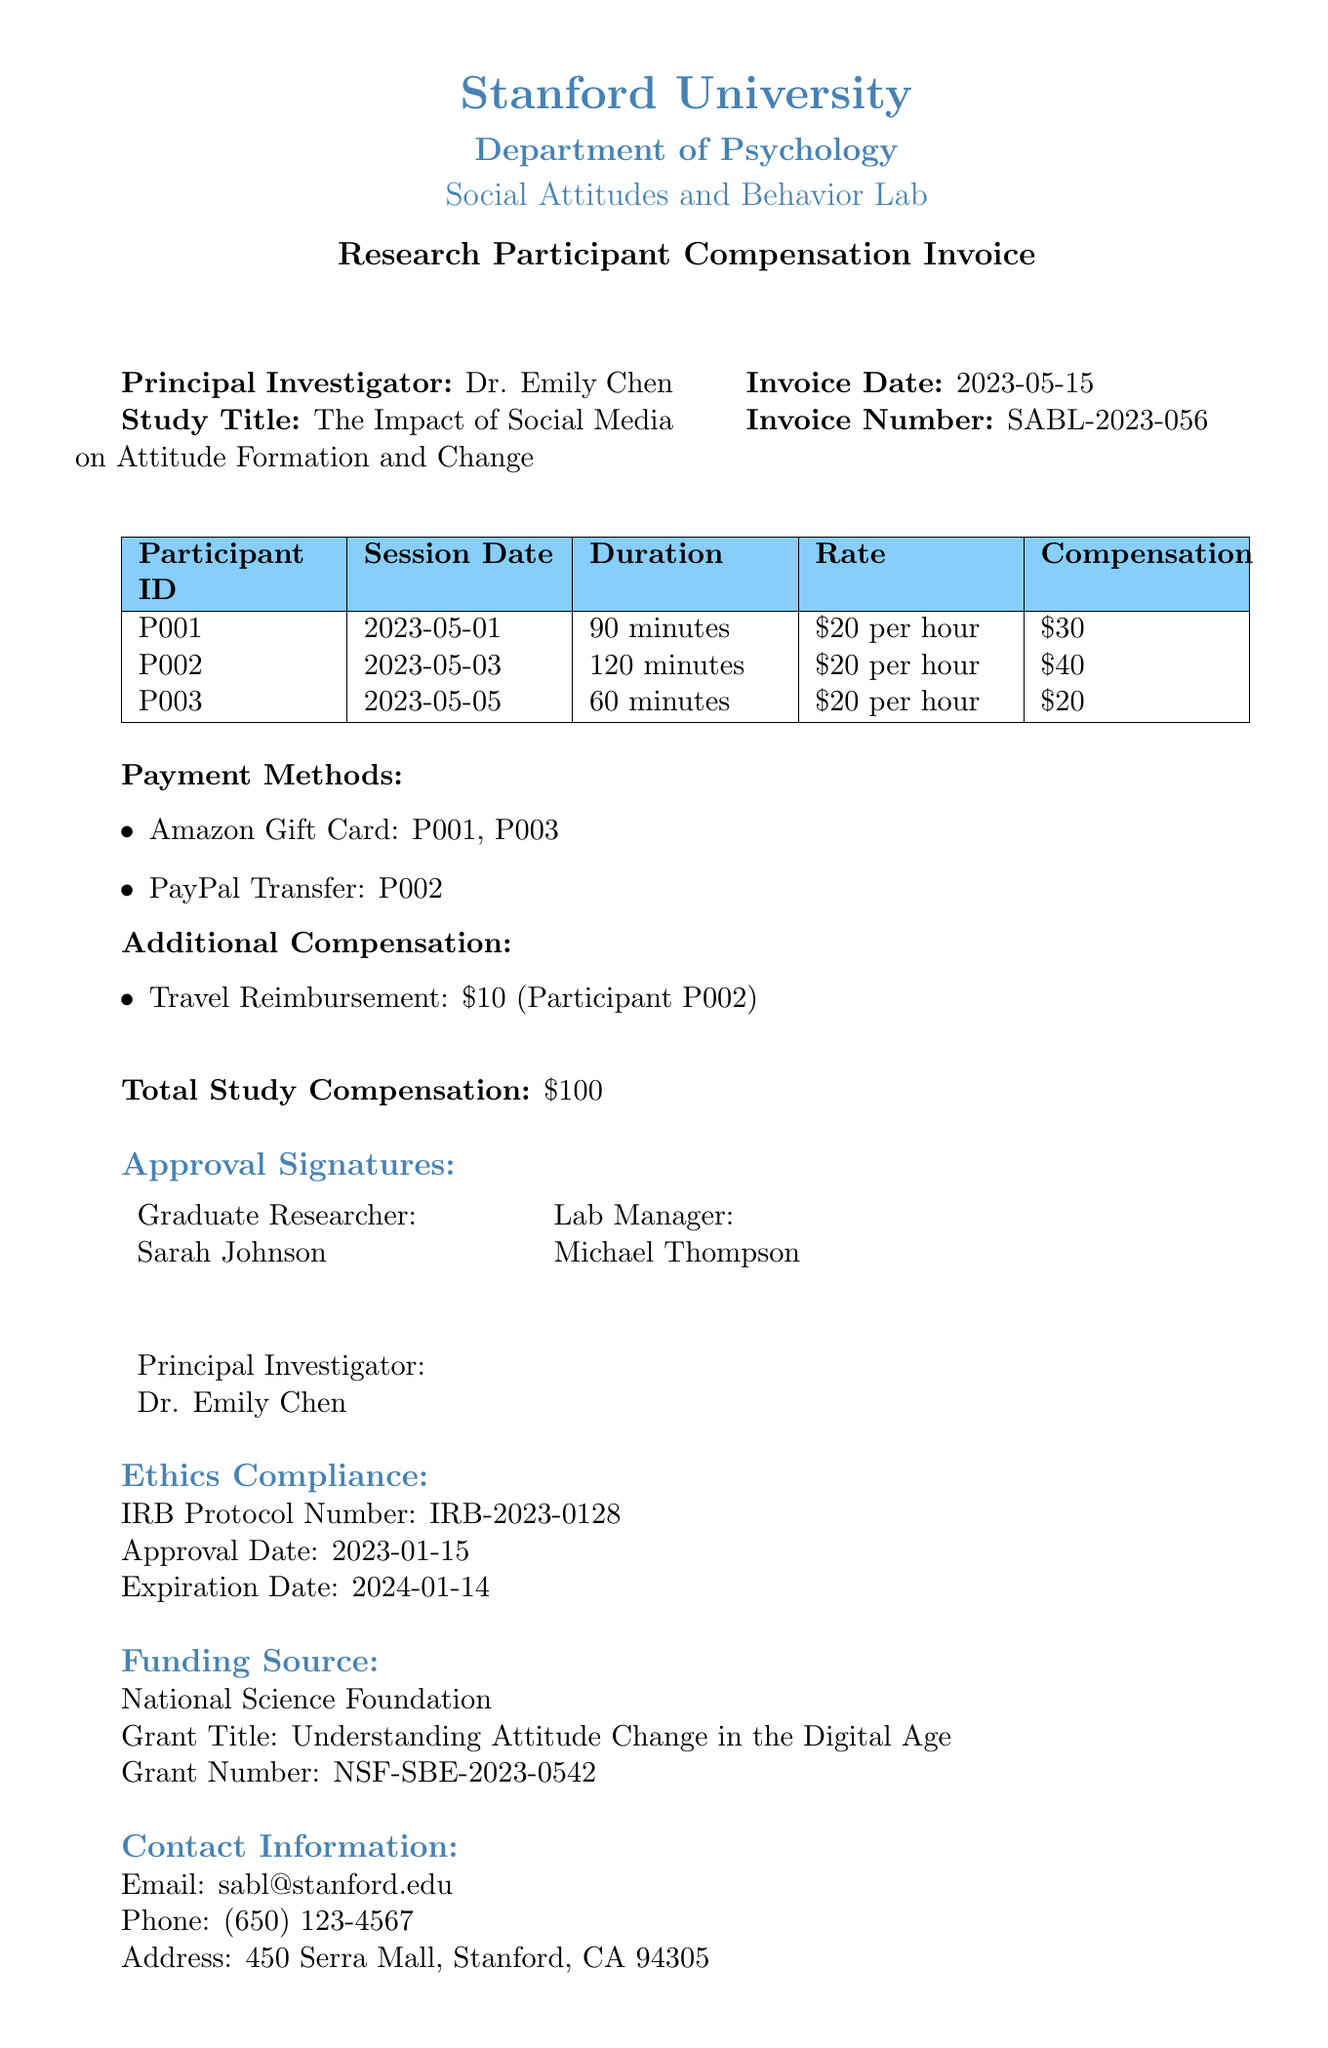what is the invoice date? The invoice date is specifically mentioned in the document header as the date when the invoice was issued.
Answer: 2023-05-15 who is the principal investigator? The principal investigator is listed at the top of the document, indicating the lead researcher for the study.
Answer: Dr. Emily Chen how much was participant P002 compensated? The total compensation for participant P002 is explicitly stated in the table detailing participant details.
Answer: $40 what is the total study compensation? The total study compensation is calculated based on all compensations listed for the participants in the document.
Answer: $100 which funding source is mentioned? The document specifically lists the funding source in the appropriate section, including the organization behind it.
Answer: National Science Foundation how many participants were compensated? The document includes a list of participants who were compensated, which can be counted from the detail section.
Answer: 3 what type of additional compensation was provided to participant P002? The document lists types of additional compensation given to participants, which includes a specific category for one participant.
Answer: Travel Reimbursement what payment method was used for participant P001? The payment methods listed in the document specify which methods were used for each participant’s compensation.
Answer: Amazon Gift Card what is the IRB protocol number? The IRB protocol number is a critical piece of information provided in the ethics compliance section of the invoice.
Answer: IRB-2023-0128 